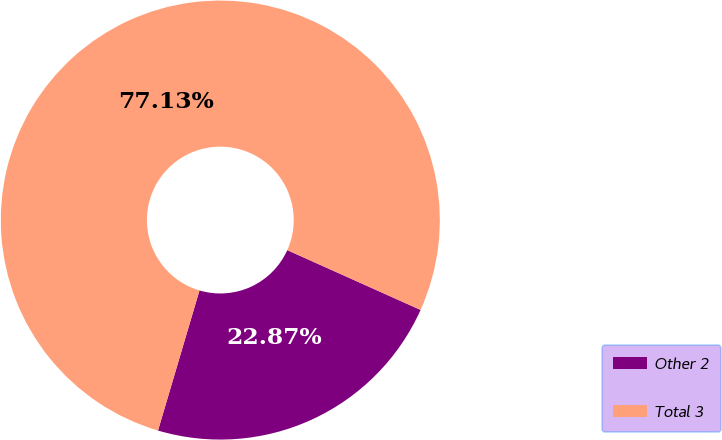<chart> <loc_0><loc_0><loc_500><loc_500><pie_chart><fcel>Other 2<fcel>Total 3<nl><fcel>22.87%<fcel>77.13%<nl></chart> 